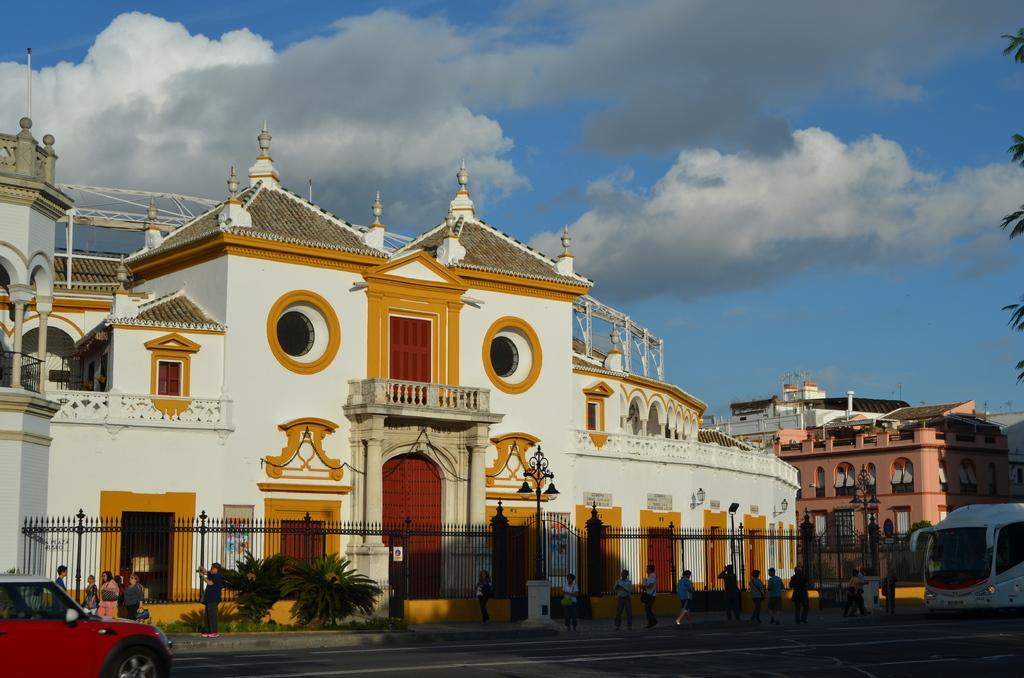How would you summarize this image in a sentence or two? In this image we can see sky with clouds, buildings, street poles, street lights, iron grill, trees, plants, motor vehicles, electric cables and persons on the road. 